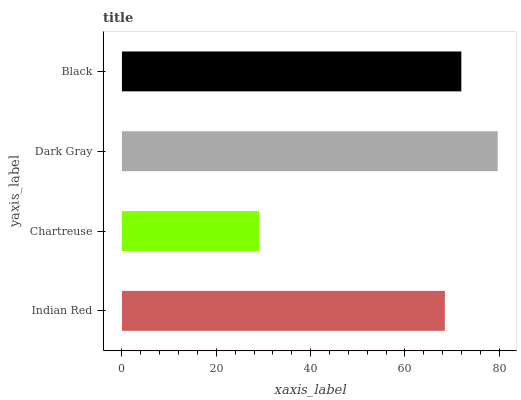Is Chartreuse the minimum?
Answer yes or no. Yes. Is Dark Gray the maximum?
Answer yes or no. Yes. Is Dark Gray the minimum?
Answer yes or no. No. Is Chartreuse the maximum?
Answer yes or no. No. Is Dark Gray greater than Chartreuse?
Answer yes or no. Yes. Is Chartreuse less than Dark Gray?
Answer yes or no. Yes. Is Chartreuse greater than Dark Gray?
Answer yes or no. No. Is Dark Gray less than Chartreuse?
Answer yes or no. No. Is Black the high median?
Answer yes or no. Yes. Is Indian Red the low median?
Answer yes or no. Yes. Is Dark Gray the high median?
Answer yes or no. No. Is Dark Gray the low median?
Answer yes or no. No. 